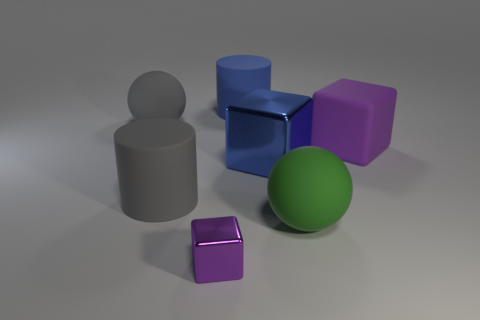There is a cube that is to the right of the green rubber thing; is its color the same as the metal object in front of the green matte sphere?
Your answer should be compact. Yes. The large object that is both to the left of the small metallic block and in front of the large gray rubber ball is what color?
Provide a short and direct response. Gray. What number of other things are the same shape as the green object?
Ensure brevity in your answer.  1. There is another rubber ball that is the same size as the gray ball; what color is it?
Provide a succinct answer. Green. What is the color of the metal thing that is in front of the big blue metal object?
Make the answer very short. Purple. There is a big gray thing that is behind the large purple object; are there any big rubber things in front of it?
Provide a short and direct response. Yes. Do the tiny purple thing and the big gray thing behind the large blue cube have the same shape?
Your answer should be compact. No. What is the size of the object that is in front of the large gray cylinder and on the left side of the big blue metallic cube?
Provide a short and direct response. Small. Are there any large gray blocks that have the same material as the large purple object?
Provide a succinct answer. No. There is a object that is the same color as the rubber cube; what size is it?
Keep it short and to the point. Small. 